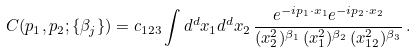<formula> <loc_0><loc_0><loc_500><loc_500>C ( p _ { 1 } , p _ { 2 } ; \{ \beta _ { j } \} ) = c _ { 1 2 3 } \int d ^ { d } x _ { 1 } d ^ { d } x _ { 2 } \, \frac { e ^ { - i p _ { 1 } \cdot x _ { 1 } } e ^ { - i p _ { 2 } \cdot x _ { 2 } } } { ( x _ { 2 } ^ { 2 } ) ^ { \beta _ { 1 } } \, ( x _ { 1 } ^ { 2 } ) ^ { \beta _ { 2 } } \, ( x _ { 1 2 } ^ { 2 } ) ^ { \beta _ { 3 } } } \, .</formula> 